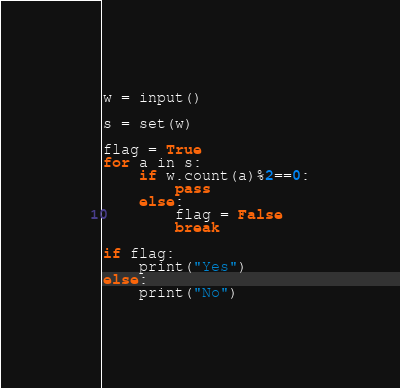<code> <loc_0><loc_0><loc_500><loc_500><_Python_>w = input()

s = set(w)

flag = True
for a in s:
    if w.count(a)%2==0:
        pass
    else:
        flag = False
        break

if flag:
    print("Yes")
else:
    print("No")
</code> 